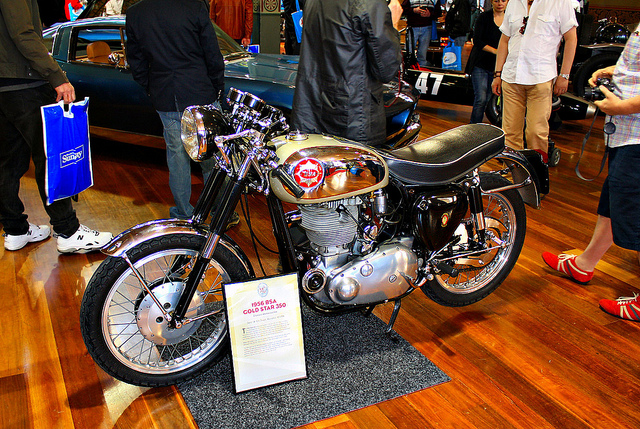Please extract the text content from this image. RSA COLD STAR 47 